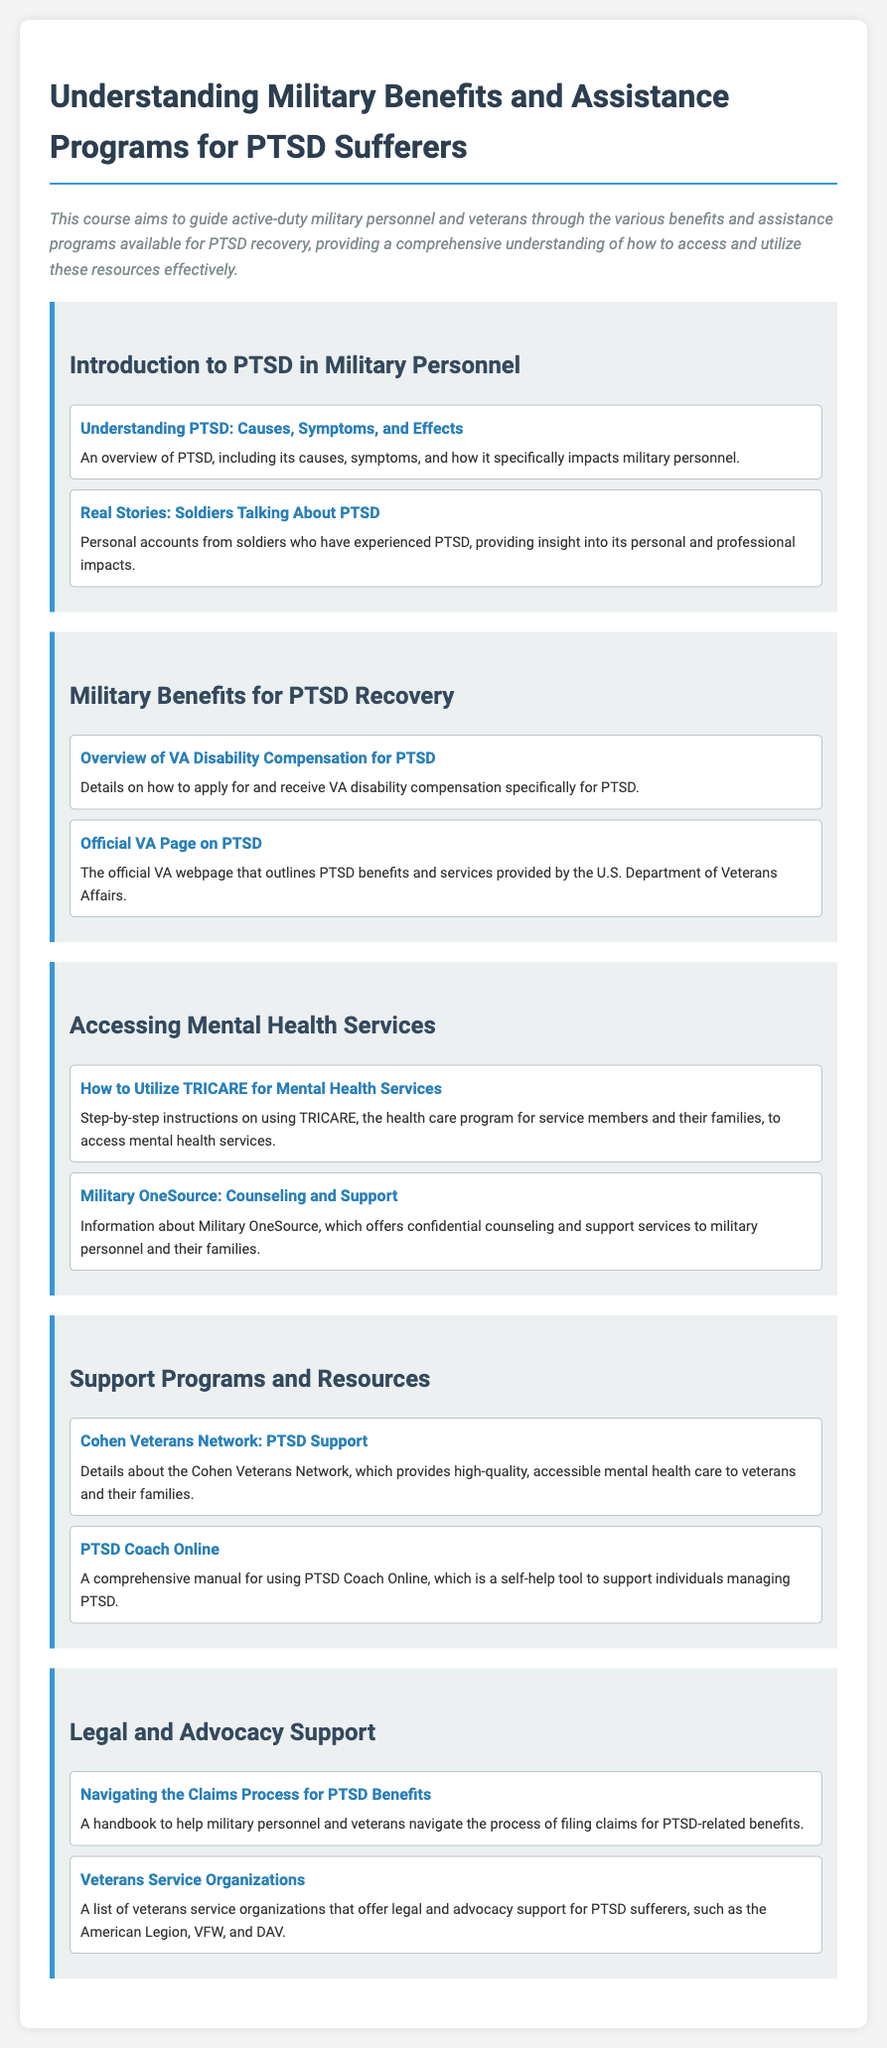What is the title of the syllabus? The title of the syllabus is presented at the top of the document.
Answer: Understanding Military Benefits and Assistance Programs for PTSD Sufferers What is the purpose of the course? The purpose is described in the introductory paragraph as guiding military personnel and veterans through various benefits for PTSD recovery.
Answer: To guide active-duty military personnel and veterans through various benefits and assistance programs available for PTSD recovery What are two main topics covered in the introduction? The introduction section includes an overview of PTSD and personal accounts from soldiers.
Answer: Understanding PTSD: Causes, Symptoms, and Effects; Real Stories: Soldiers Talking About PTSD What program is mentioned for accessing mental health services? The document specifically mentions a healthcare program related to service members and their families.
Answer: TRICARE Which organization provides accessible mental health care to veterans? The document mentions a specific organization that focuses on mental health care for veterans and their families.
Answer: Cohen Veterans Network What tool is introduced to help manage PTSD? A specific online tool that supports individuals in managing PTSD is mentioned in the support programs section.
Answer: PTSD Coach Online What is the aim of the handbook provided in the legal and advocacy support section? The handbook aims to assist military personnel and veterans with a specific process related to PTSD benefits.
Answer: To navigate the claims process for PTSD benefits Name one veterans service organization listed in the syllabus. The document provides examples of organizations that offer legal and advocacy support.
Answer: American Legion 